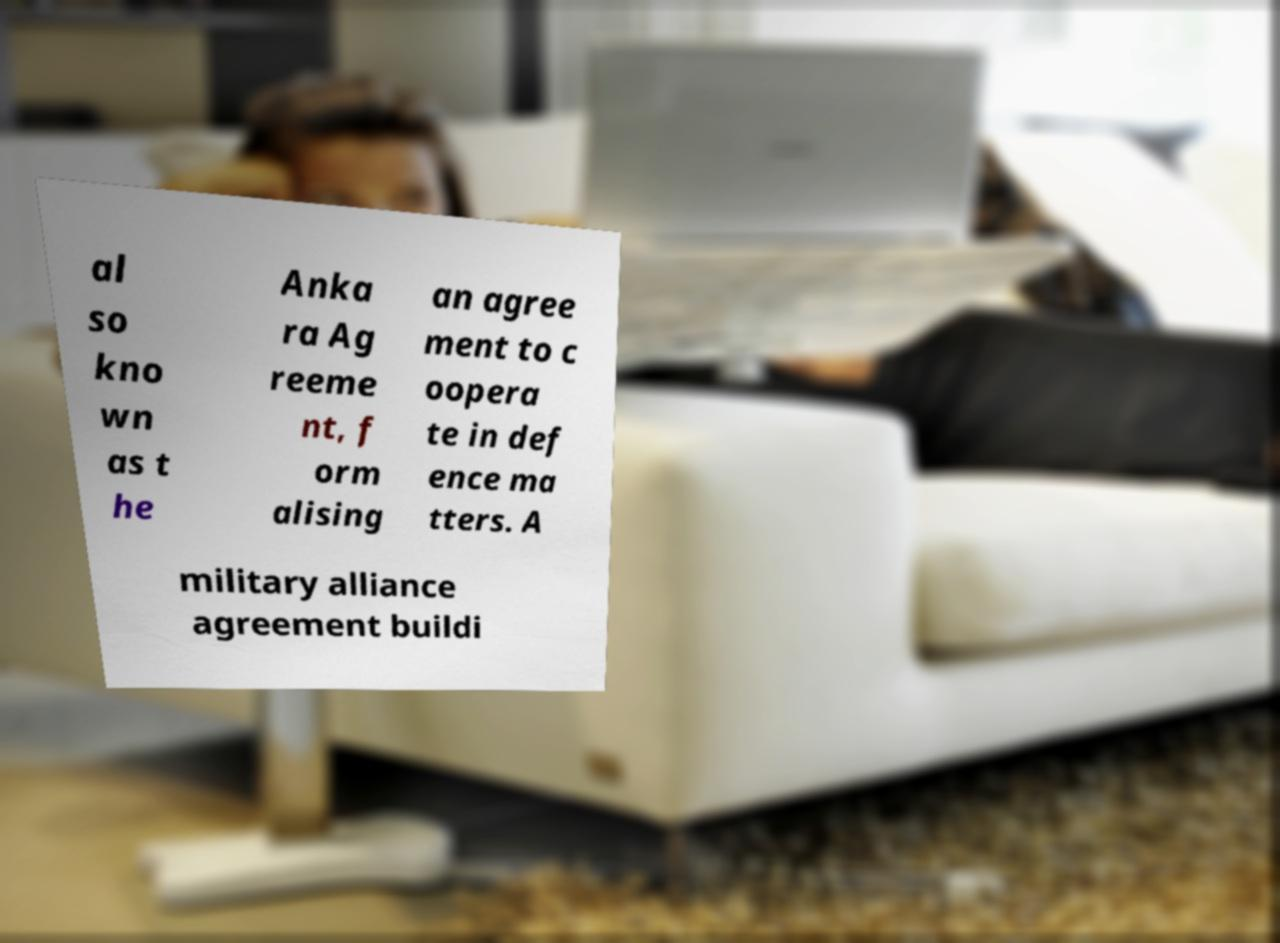What messages or text are displayed in this image? I need them in a readable, typed format. al so kno wn as t he Anka ra Ag reeme nt, f orm alising an agree ment to c oopera te in def ence ma tters. A military alliance agreement buildi 